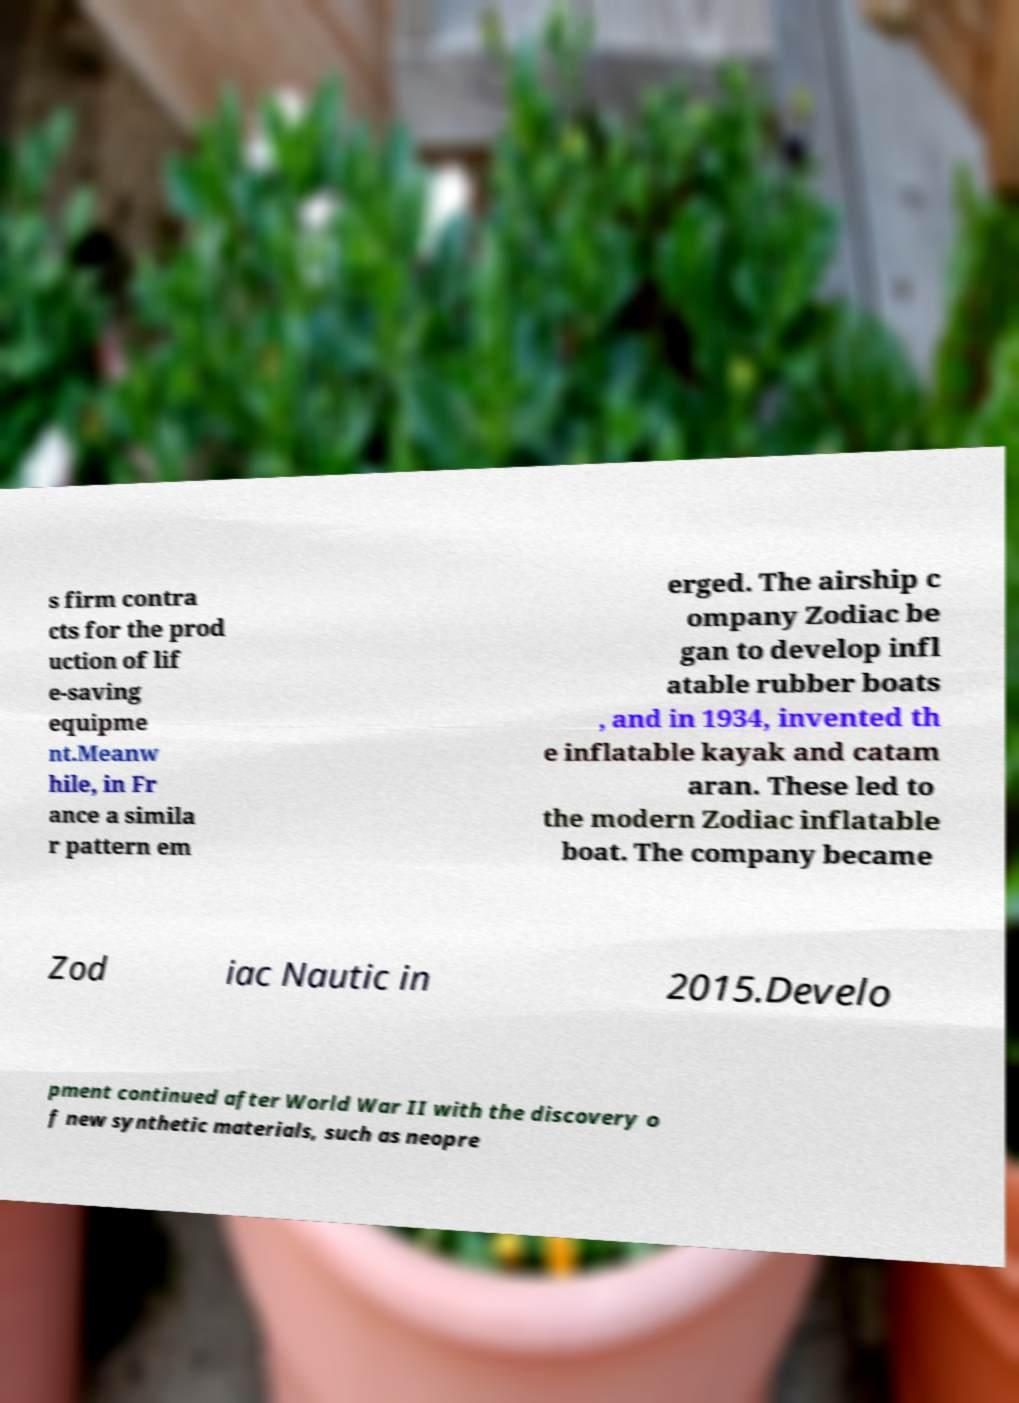Please read and relay the text visible in this image. What does it say? s firm contra cts for the prod uction of lif e-saving equipme nt.Meanw hile, in Fr ance a simila r pattern em erged. The airship c ompany Zodiac be gan to develop infl atable rubber boats , and in 1934, invented th e inflatable kayak and catam aran. These led to the modern Zodiac inflatable boat. The company became Zod iac Nautic in 2015.Develo pment continued after World War II with the discovery o f new synthetic materials, such as neopre 